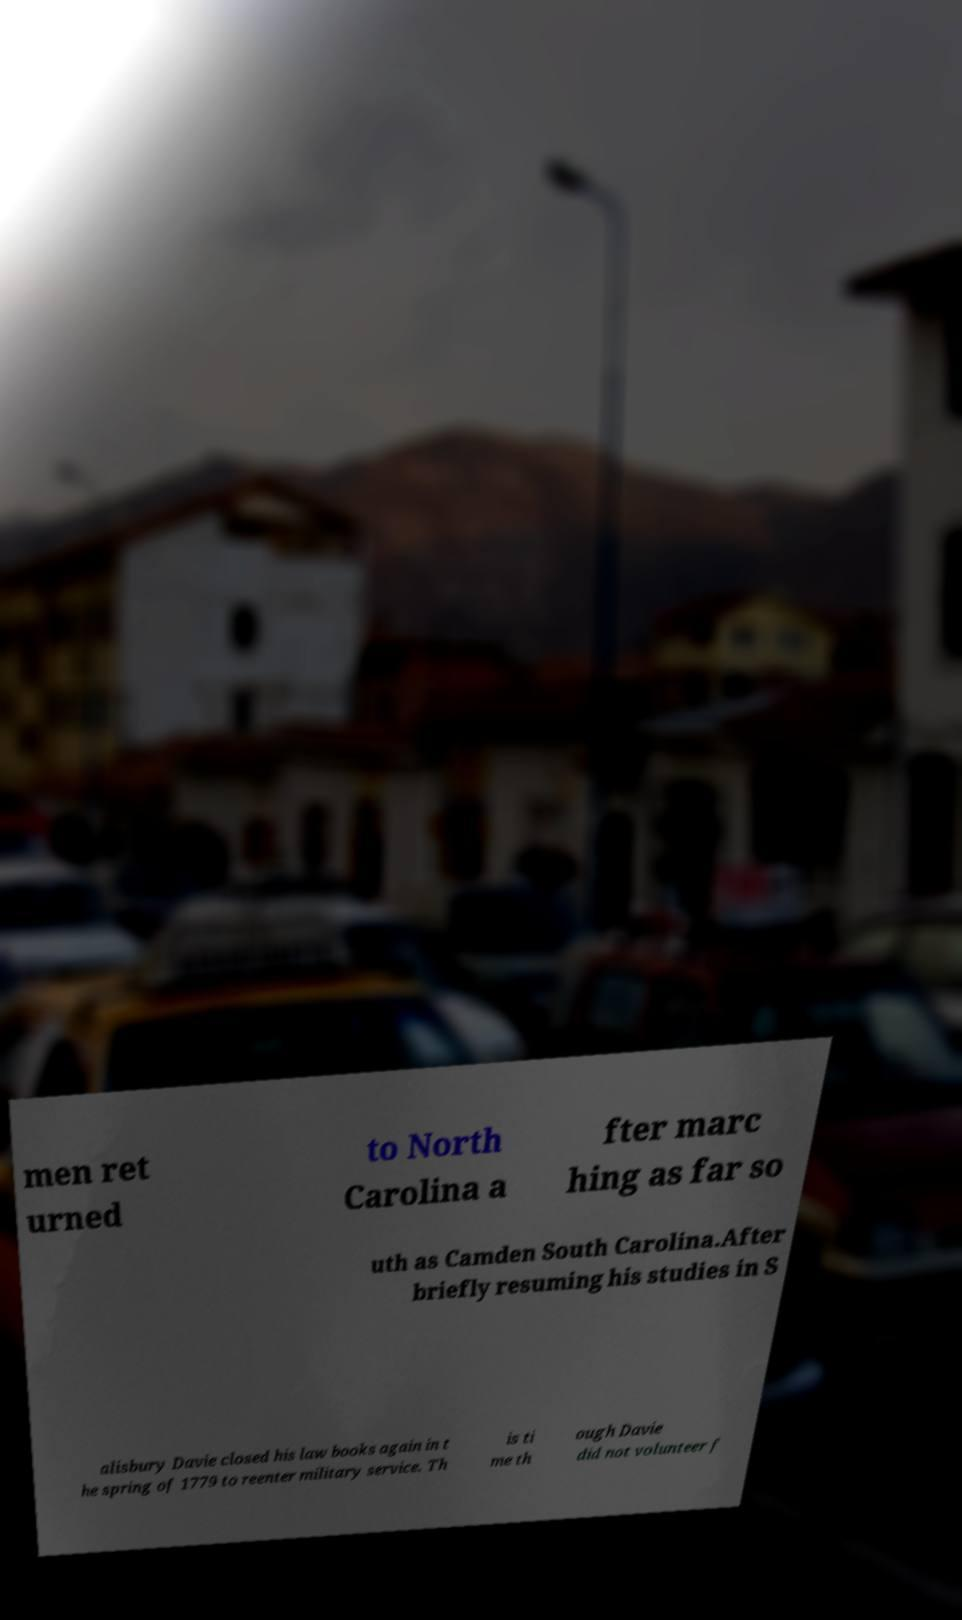Could you extract and type out the text from this image? men ret urned to North Carolina a fter marc hing as far so uth as Camden South Carolina.After briefly resuming his studies in S alisbury Davie closed his law books again in t he spring of 1779 to reenter military service. Th is ti me th ough Davie did not volunteer f 